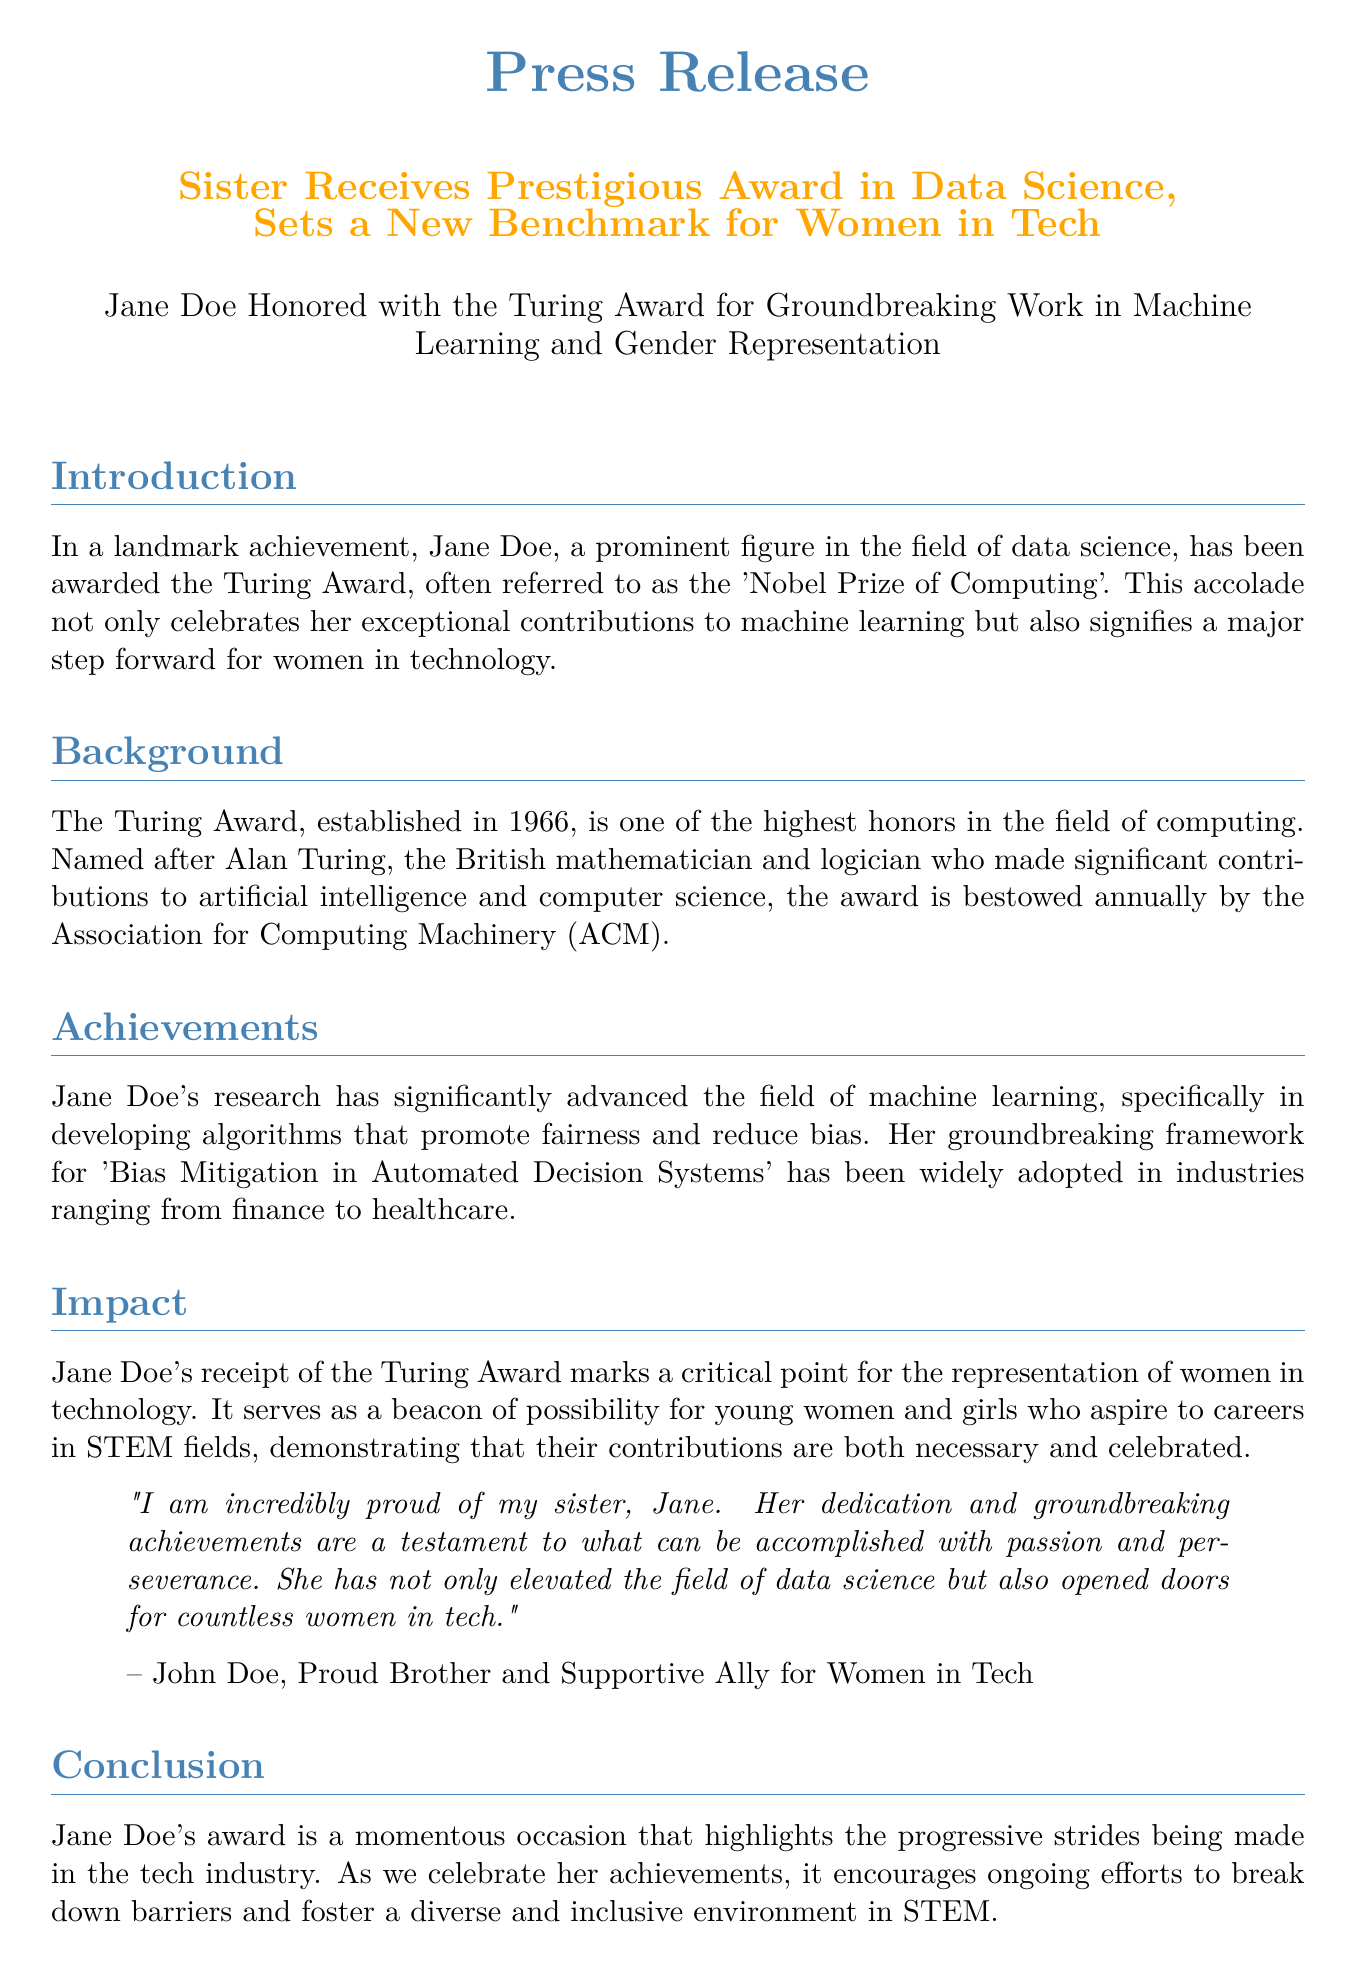What award did Jane Doe receive? The document states that Jane Doe was awarded the Turing Award.
Answer: Turing Award What significant topic did Jane Doe's research focus on? The document mentions that her research significantly advanced the field of machine learning, particularly in developing algorithms.
Answer: machine learning In what year was the Turing Award established? The document provides that the Turing Award was established in 1966.
Answer: 1966 Who is the Turing Award named after? The document states that the award is named after Alan Turing.
Answer: Alan Turing What does Jane Doe's achievement represent for women in technology? The document describes her achievement as a beacon of possibility for young women and girls in STEM fields.
Answer: beacon of possibility How does Jane Doe's award impact young women? The document explains that it demonstrates that their contributions are both necessary and celebrated.
Answer: necessary and celebrated What is the primary aim of Jane Doe's framework mentioned in the document? The document indicates that her framework is for 'Bias Mitigation in Automated Decision Systems'.
Answer: Bias Mitigation in Automated Decision Systems What does the press release ultimately celebrate? The final part of the document states it celebrates Jane Doe's achievements and the strides in the tech industry.
Answer: Jane Doe's achievements Who is quoted in the press release? The document states that John Doe is quoted expressing pride in his sister.
Answer: John Doe 